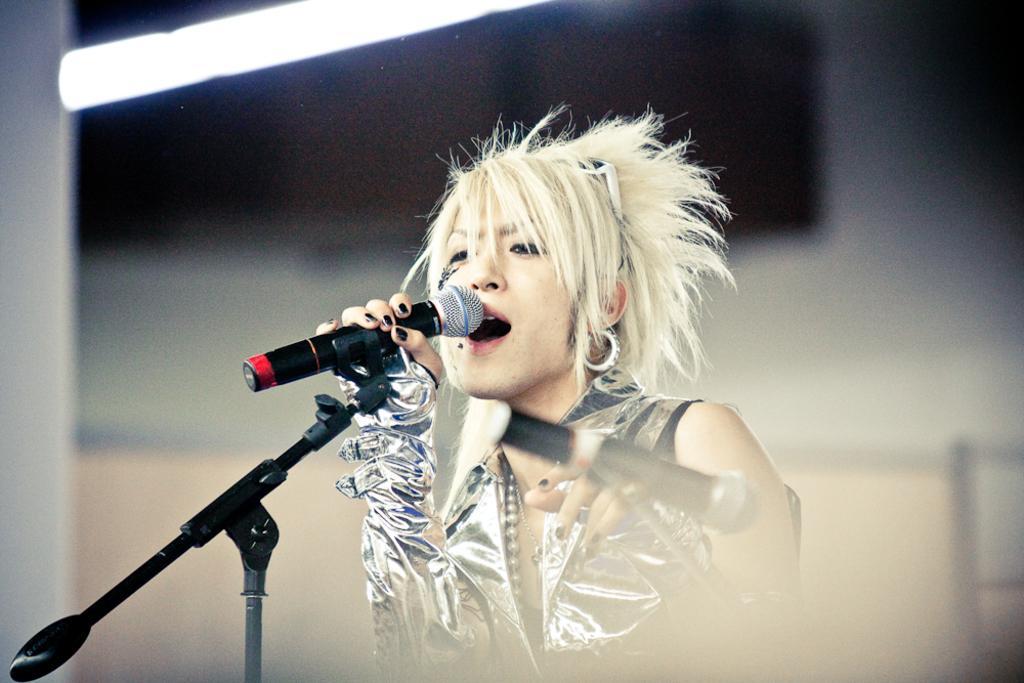How would you summarize this image in a sentence or two? This is the picture of a woman in silver dress, the woman is singing a song. In front of the man there is a microphone with stand and the woman is holding a microphone. Behind the woman is in blue. 